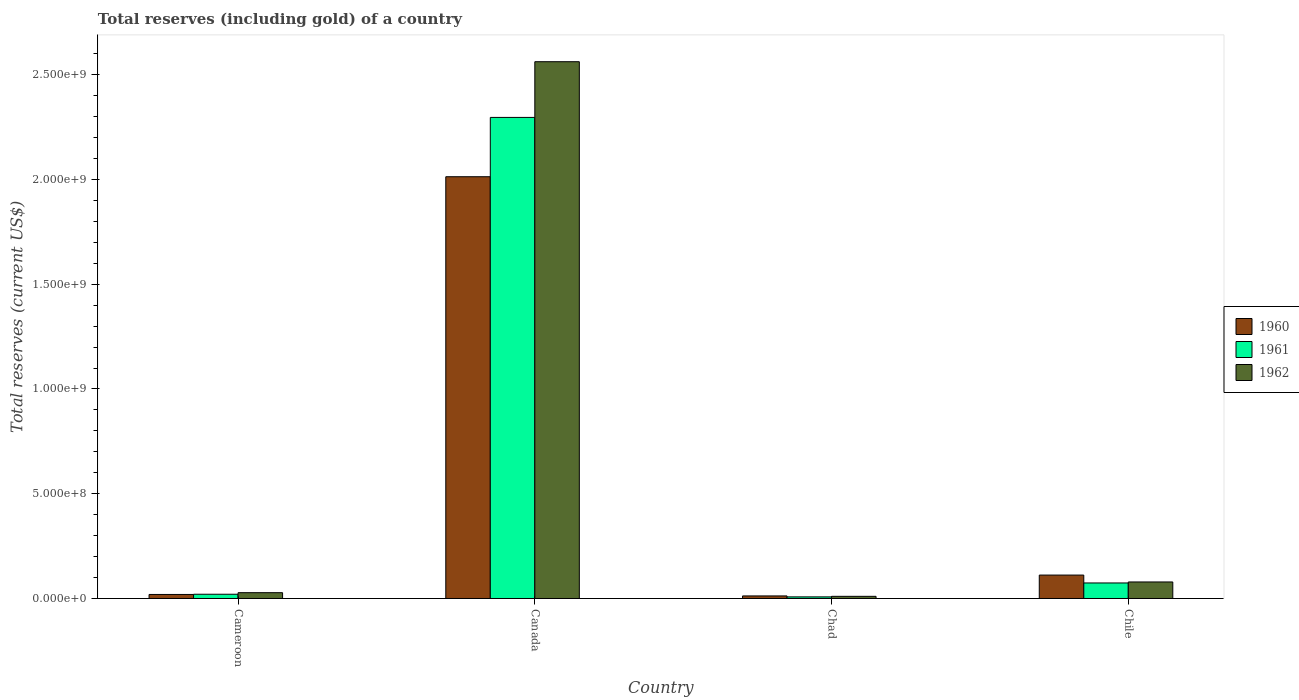How many different coloured bars are there?
Ensure brevity in your answer.  3. Are the number of bars per tick equal to the number of legend labels?
Provide a succinct answer. Yes. What is the label of the 2nd group of bars from the left?
Offer a terse response. Canada. What is the total reserves (including gold) in 1960 in Canada?
Your answer should be compact. 2.01e+09. Across all countries, what is the maximum total reserves (including gold) in 1962?
Give a very brief answer. 2.56e+09. Across all countries, what is the minimum total reserves (including gold) in 1960?
Provide a succinct answer. 1.22e+07. In which country was the total reserves (including gold) in 1962 minimum?
Give a very brief answer. Chad. What is the total total reserves (including gold) in 1961 in the graph?
Keep it short and to the point. 2.40e+09. What is the difference between the total reserves (including gold) in 1962 in Cameroon and that in Canada?
Keep it short and to the point. -2.53e+09. What is the difference between the total reserves (including gold) in 1962 in Cameroon and the total reserves (including gold) in 1960 in Chad?
Give a very brief answer. 1.55e+07. What is the average total reserves (including gold) in 1962 per country?
Provide a succinct answer. 6.70e+08. What is the difference between the total reserves (including gold) of/in 1962 and total reserves (including gold) of/in 1960 in Chad?
Offer a terse response. -1.94e+06. In how many countries, is the total reserves (including gold) in 1960 greater than 1700000000 US$?
Make the answer very short. 1. What is the ratio of the total reserves (including gold) in 1960 in Cameroon to that in Chad?
Give a very brief answer. 1.57. Is the total reserves (including gold) in 1960 in Cameroon less than that in Chile?
Keep it short and to the point. Yes. Is the difference between the total reserves (including gold) in 1962 in Canada and Chad greater than the difference between the total reserves (including gold) in 1960 in Canada and Chad?
Make the answer very short. Yes. What is the difference between the highest and the second highest total reserves (including gold) in 1962?
Offer a terse response. -2.53e+09. What is the difference between the highest and the lowest total reserves (including gold) in 1960?
Your answer should be very brief. 2.00e+09. In how many countries, is the total reserves (including gold) in 1962 greater than the average total reserves (including gold) in 1962 taken over all countries?
Your response must be concise. 1. Is the sum of the total reserves (including gold) in 1961 in Chad and Chile greater than the maximum total reserves (including gold) in 1960 across all countries?
Your answer should be very brief. No. What does the 1st bar from the right in Cameroon represents?
Your response must be concise. 1962. Is it the case that in every country, the sum of the total reserves (including gold) in 1962 and total reserves (including gold) in 1960 is greater than the total reserves (including gold) in 1961?
Ensure brevity in your answer.  Yes. Are all the bars in the graph horizontal?
Provide a short and direct response. No. How many countries are there in the graph?
Keep it short and to the point. 4. What is the difference between two consecutive major ticks on the Y-axis?
Your response must be concise. 5.00e+08. Are the values on the major ticks of Y-axis written in scientific E-notation?
Your answer should be very brief. Yes. How are the legend labels stacked?
Offer a terse response. Vertical. What is the title of the graph?
Make the answer very short. Total reserves (including gold) of a country. Does "1992" appear as one of the legend labels in the graph?
Your answer should be compact. No. What is the label or title of the Y-axis?
Your response must be concise. Total reserves (current US$). What is the Total reserves (current US$) in 1960 in Cameroon?
Ensure brevity in your answer.  1.92e+07. What is the Total reserves (current US$) in 1961 in Cameroon?
Provide a succinct answer. 2.03e+07. What is the Total reserves (current US$) in 1962 in Cameroon?
Your response must be concise. 2.77e+07. What is the Total reserves (current US$) in 1960 in Canada?
Your answer should be compact. 2.01e+09. What is the Total reserves (current US$) in 1961 in Canada?
Your response must be concise. 2.30e+09. What is the Total reserves (current US$) in 1962 in Canada?
Your response must be concise. 2.56e+09. What is the Total reserves (current US$) of 1960 in Chad?
Make the answer very short. 1.22e+07. What is the Total reserves (current US$) in 1961 in Chad?
Keep it short and to the point. 7.69e+06. What is the Total reserves (current US$) of 1962 in Chad?
Offer a terse response. 1.03e+07. What is the Total reserves (current US$) in 1960 in Chile?
Your response must be concise. 1.12e+08. What is the Total reserves (current US$) in 1961 in Chile?
Your answer should be compact. 7.41e+07. What is the Total reserves (current US$) in 1962 in Chile?
Ensure brevity in your answer.  7.89e+07. Across all countries, what is the maximum Total reserves (current US$) of 1960?
Provide a short and direct response. 2.01e+09. Across all countries, what is the maximum Total reserves (current US$) in 1961?
Provide a succinct answer. 2.30e+09. Across all countries, what is the maximum Total reserves (current US$) of 1962?
Provide a short and direct response. 2.56e+09. Across all countries, what is the minimum Total reserves (current US$) in 1960?
Provide a succinct answer. 1.22e+07. Across all countries, what is the minimum Total reserves (current US$) in 1961?
Your answer should be very brief. 7.69e+06. Across all countries, what is the minimum Total reserves (current US$) of 1962?
Offer a very short reply. 1.03e+07. What is the total Total reserves (current US$) of 1960 in the graph?
Provide a succinct answer. 2.16e+09. What is the total Total reserves (current US$) in 1961 in the graph?
Make the answer very short. 2.40e+09. What is the total Total reserves (current US$) in 1962 in the graph?
Your response must be concise. 2.68e+09. What is the difference between the Total reserves (current US$) in 1960 in Cameroon and that in Canada?
Ensure brevity in your answer.  -1.99e+09. What is the difference between the Total reserves (current US$) of 1961 in Cameroon and that in Canada?
Make the answer very short. -2.28e+09. What is the difference between the Total reserves (current US$) in 1962 in Cameroon and that in Canada?
Offer a very short reply. -2.53e+09. What is the difference between the Total reserves (current US$) in 1960 in Cameroon and that in Chad?
Keep it short and to the point. 7.00e+06. What is the difference between the Total reserves (current US$) in 1961 in Cameroon and that in Chad?
Your answer should be compact. 1.26e+07. What is the difference between the Total reserves (current US$) in 1962 in Cameroon and that in Chad?
Make the answer very short. 1.74e+07. What is the difference between the Total reserves (current US$) in 1960 in Cameroon and that in Chile?
Your answer should be very brief. -9.25e+07. What is the difference between the Total reserves (current US$) of 1961 in Cameroon and that in Chile?
Keep it short and to the point. -5.38e+07. What is the difference between the Total reserves (current US$) of 1962 in Cameroon and that in Chile?
Provide a short and direct response. -5.12e+07. What is the difference between the Total reserves (current US$) in 1960 in Canada and that in Chad?
Offer a very short reply. 2.00e+09. What is the difference between the Total reserves (current US$) of 1961 in Canada and that in Chad?
Your response must be concise. 2.29e+09. What is the difference between the Total reserves (current US$) in 1962 in Canada and that in Chad?
Provide a short and direct response. 2.55e+09. What is the difference between the Total reserves (current US$) of 1960 in Canada and that in Chile?
Offer a terse response. 1.90e+09. What is the difference between the Total reserves (current US$) of 1961 in Canada and that in Chile?
Provide a short and direct response. 2.22e+09. What is the difference between the Total reserves (current US$) in 1962 in Canada and that in Chile?
Your response must be concise. 2.48e+09. What is the difference between the Total reserves (current US$) of 1960 in Chad and that in Chile?
Your answer should be compact. -9.95e+07. What is the difference between the Total reserves (current US$) in 1961 in Chad and that in Chile?
Offer a terse response. -6.64e+07. What is the difference between the Total reserves (current US$) of 1962 in Chad and that in Chile?
Offer a very short reply. -6.86e+07. What is the difference between the Total reserves (current US$) of 1960 in Cameroon and the Total reserves (current US$) of 1961 in Canada?
Make the answer very short. -2.28e+09. What is the difference between the Total reserves (current US$) of 1960 in Cameroon and the Total reserves (current US$) of 1962 in Canada?
Give a very brief answer. -2.54e+09. What is the difference between the Total reserves (current US$) in 1961 in Cameroon and the Total reserves (current US$) in 1962 in Canada?
Offer a very short reply. -2.54e+09. What is the difference between the Total reserves (current US$) of 1960 in Cameroon and the Total reserves (current US$) of 1961 in Chad?
Keep it short and to the point. 1.16e+07. What is the difference between the Total reserves (current US$) in 1960 in Cameroon and the Total reserves (current US$) in 1962 in Chad?
Your answer should be compact. 8.94e+06. What is the difference between the Total reserves (current US$) of 1960 in Cameroon and the Total reserves (current US$) of 1961 in Chile?
Provide a succinct answer. -5.49e+07. What is the difference between the Total reserves (current US$) in 1960 in Cameroon and the Total reserves (current US$) in 1962 in Chile?
Your answer should be very brief. -5.97e+07. What is the difference between the Total reserves (current US$) in 1961 in Cameroon and the Total reserves (current US$) in 1962 in Chile?
Ensure brevity in your answer.  -5.86e+07. What is the difference between the Total reserves (current US$) of 1960 in Canada and the Total reserves (current US$) of 1961 in Chad?
Your answer should be compact. 2.01e+09. What is the difference between the Total reserves (current US$) of 1960 in Canada and the Total reserves (current US$) of 1962 in Chad?
Your answer should be compact. 2.00e+09. What is the difference between the Total reserves (current US$) in 1961 in Canada and the Total reserves (current US$) in 1962 in Chad?
Your answer should be compact. 2.29e+09. What is the difference between the Total reserves (current US$) of 1960 in Canada and the Total reserves (current US$) of 1961 in Chile?
Offer a very short reply. 1.94e+09. What is the difference between the Total reserves (current US$) in 1960 in Canada and the Total reserves (current US$) in 1962 in Chile?
Provide a short and direct response. 1.93e+09. What is the difference between the Total reserves (current US$) of 1961 in Canada and the Total reserves (current US$) of 1962 in Chile?
Ensure brevity in your answer.  2.22e+09. What is the difference between the Total reserves (current US$) in 1960 in Chad and the Total reserves (current US$) in 1961 in Chile?
Your answer should be very brief. -6.19e+07. What is the difference between the Total reserves (current US$) in 1960 in Chad and the Total reserves (current US$) in 1962 in Chile?
Give a very brief answer. -6.67e+07. What is the difference between the Total reserves (current US$) in 1961 in Chad and the Total reserves (current US$) in 1962 in Chile?
Make the answer very short. -7.12e+07. What is the average Total reserves (current US$) of 1960 per country?
Offer a terse response. 5.39e+08. What is the average Total reserves (current US$) in 1961 per country?
Your answer should be very brief. 6.00e+08. What is the average Total reserves (current US$) in 1962 per country?
Your answer should be compact. 6.70e+08. What is the difference between the Total reserves (current US$) of 1960 and Total reserves (current US$) of 1961 in Cameroon?
Provide a short and direct response. -1.06e+06. What is the difference between the Total reserves (current US$) of 1960 and Total reserves (current US$) of 1962 in Cameroon?
Provide a succinct answer. -8.47e+06. What is the difference between the Total reserves (current US$) in 1961 and Total reserves (current US$) in 1962 in Cameroon?
Make the answer very short. -7.41e+06. What is the difference between the Total reserves (current US$) in 1960 and Total reserves (current US$) in 1961 in Canada?
Provide a succinct answer. -2.83e+08. What is the difference between the Total reserves (current US$) in 1960 and Total reserves (current US$) in 1962 in Canada?
Offer a terse response. -5.49e+08. What is the difference between the Total reserves (current US$) of 1961 and Total reserves (current US$) of 1962 in Canada?
Your answer should be very brief. -2.66e+08. What is the difference between the Total reserves (current US$) in 1960 and Total reserves (current US$) in 1961 in Chad?
Keep it short and to the point. 4.55e+06. What is the difference between the Total reserves (current US$) in 1960 and Total reserves (current US$) in 1962 in Chad?
Provide a succinct answer. 1.94e+06. What is the difference between the Total reserves (current US$) of 1961 and Total reserves (current US$) of 1962 in Chad?
Provide a short and direct response. -2.61e+06. What is the difference between the Total reserves (current US$) of 1960 and Total reserves (current US$) of 1961 in Chile?
Provide a short and direct response. 3.77e+07. What is the difference between the Total reserves (current US$) of 1960 and Total reserves (current US$) of 1962 in Chile?
Your response must be concise. 3.29e+07. What is the difference between the Total reserves (current US$) in 1961 and Total reserves (current US$) in 1962 in Chile?
Your answer should be compact. -4.78e+06. What is the ratio of the Total reserves (current US$) in 1960 in Cameroon to that in Canada?
Ensure brevity in your answer.  0.01. What is the ratio of the Total reserves (current US$) of 1961 in Cameroon to that in Canada?
Provide a succinct answer. 0.01. What is the ratio of the Total reserves (current US$) of 1962 in Cameroon to that in Canada?
Provide a short and direct response. 0.01. What is the ratio of the Total reserves (current US$) in 1960 in Cameroon to that in Chad?
Your response must be concise. 1.57. What is the ratio of the Total reserves (current US$) in 1961 in Cameroon to that in Chad?
Give a very brief answer. 2.64. What is the ratio of the Total reserves (current US$) of 1962 in Cameroon to that in Chad?
Make the answer very short. 2.69. What is the ratio of the Total reserves (current US$) of 1960 in Cameroon to that in Chile?
Your response must be concise. 0.17. What is the ratio of the Total reserves (current US$) of 1961 in Cameroon to that in Chile?
Offer a very short reply. 0.27. What is the ratio of the Total reserves (current US$) in 1962 in Cameroon to that in Chile?
Your answer should be compact. 0.35. What is the ratio of the Total reserves (current US$) in 1960 in Canada to that in Chad?
Give a very brief answer. 164.46. What is the ratio of the Total reserves (current US$) of 1961 in Canada to that in Chad?
Your answer should be very brief. 298.58. What is the ratio of the Total reserves (current US$) of 1962 in Canada to that in Chad?
Offer a terse response. 248.73. What is the ratio of the Total reserves (current US$) of 1960 in Canada to that in Chile?
Offer a very short reply. 18.01. What is the ratio of the Total reserves (current US$) of 1961 in Canada to that in Chile?
Provide a short and direct response. 30.98. What is the ratio of the Total reserves (current US$) in 1962 in Canada to that in Chile?
Your response must be concise. 32.47. What is the ratio of the Total reserves (current US$) of 1960 in Chad to that in Chile?
Give a very brief answer. 0.11. What is the ratio of the Total reserves (current US$) in 1961 in Chad to that in Chile?
Your answer should be very brief. 0.1. What is the ratio of the Total reserves (current US$) of 1962 in Chad to that in Chile?
Your answer should be compact. 0.13. What is the difference between the highest and the second highest Total reserves (current US$) of 1960?
Make the answer very short. 1.90e+09. What is the difference between the highest and the second highest Total reserves (current US$) in 1961?
Provide a succinct answer. 2.22e+09. What is the difference between the highest and the second highest Total reserves (current US$) in 1962?
Offer a very short reply. 2.48e+09. What is the difference between the highest and the lowest Total reserves (current US$) in 1960?
Make the answer very short. 2.00e+09. What is the difference between the highest and the lowest Total reserves (current US$) of 1961?
Provide a short and direct response. 2.29e+09. What is the difference between the highest and the lowest Total reserves (current US$) in 1962?
Offer a very short reply. 2.55e+09. 